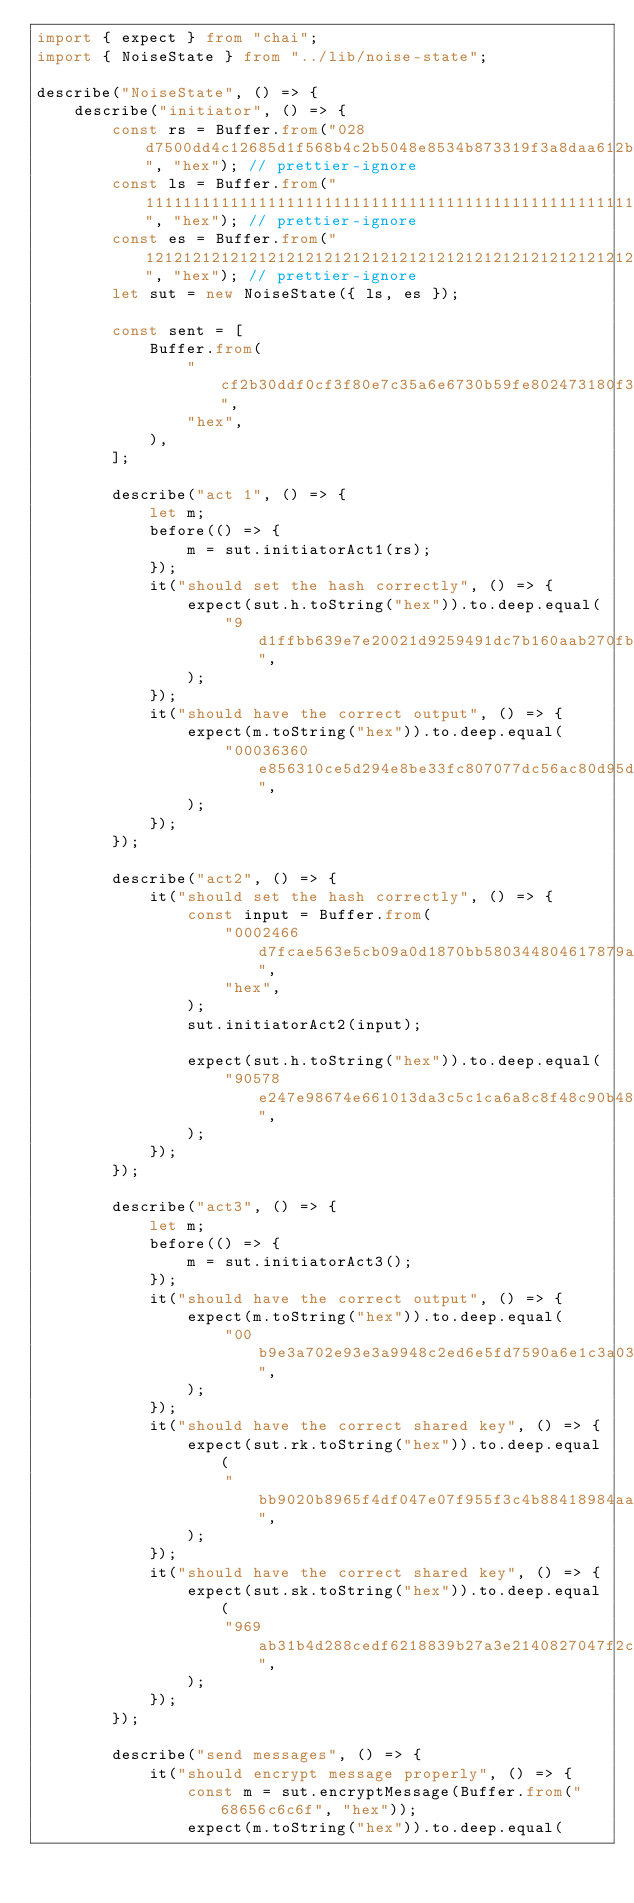Convert code to text. <code><loc_0><loc_0><loc_500><loc_500><_TypeScript_>import { expect } from "chai";
import { NoiseState } from "../lib/noise-state";

describe("NoiseState", () => {
    describe("initiator", () => {
        const rs = Buffer.from("028d7500dd4c12685d1f568b4c2b5048e8534b873319f3a8daa612b469132ec7f7", "hex"); // prettier-ignore
        const ls = Buffer.from("1111111111111111111111111111111111111111111111111111111111111111", "hex"); // prettier-ignore
        const es = Buffer.from("1212121212121212121212121212121212121212121212121212121212121212", "hex"); // prettier-ignore
        let sut = new NoiseState({ ls, es });

        const sent = [
            Buffer.from(
                "cf2b30ddf0cf3f80e7c35a6e6730b59fe802473180f396d88a8fb0db8cbcf25d2f214cf9ea1d95",
                "hex",
            ),
        ];

        describe("act 1", () => {
            let m;
            before(() => {
                m = sut.initiatorAct1(rs);
            });
            it("should set the hash correctly", () => {
                expect(sut.h.toString("hex")).to.deep.equal(
                    "9d1ffbb639e7e20021d9259491dc7b160aab270fb1339ef135053f6f2cebe9ce",
                );
            });
            it("should have the correct output", () => {
                expect(m.toString("hex")).to.deep.equal(
                    "00036360e856310ce5d294e8be33fc807077dc56ac80d95d9cd4ddbd21325eff73f70df6086551151f58b8afe6c195782c6a",
                );
            });
        });

        describe("act2", () => {
            it("should set the hash correctly", () => {
                const input = Buffer.from(
                    "0002466d7fcae563e5cb09a0d1870bb580344804617879a14949cf22285f1bae3f276e2470b93aac583c9ef6eafca3f730ae",
                    "hex",
                );
                sut.initiatorAct2(input);

                expect(sut.h.toString("hex")).to.deep.equal(
                    "90578e247e98674e661013da3c5c1ca6a8c8f48c90b485c0dfa1494e23d56d72",
                );
            });
        });

        describe("act3", () => {
            let m;
            before(() => {
                m = sut.initiatorAct3();
            });
            it("should have the correct output", () => {
                expect(m.toString("hex")).to.deep.equal(
                    "00b9e3a702e93e3a9948c2ed6e5fd7590a6e1c3a0344cfc9d5b57357049aa22355361aa02e55a8fc28fef5bd6d71ad0c38228dc68b1c466263b47fdf31e560e139ba",
                );
            });
            it("should have the correct shared key", () => {
                expect(sut.rk.toString("hex")).to.deep.equal(
                    "bb9020b8965f4df047e07f955f3c4b88418984aadc5cdb35096b9ea8fa5c3442",
                );
            });
            it("should have the correct shared key", () => {
                expect(sut.sk.toString("hex")).to.deep.equal(
                    "969ab31b4d288cedf6218839b27a3e2140827047f2c0f01bf5c04435d43511a9",
                );
            });
        });

        describe("send messages", () => {
            it("should encrypt message properly", () => {
                const m = sut.encryptMessage(Buffer.from("68656c6c6f", "hex"));
                expect(m.toString("hex")).to.deep.equal(</code> 